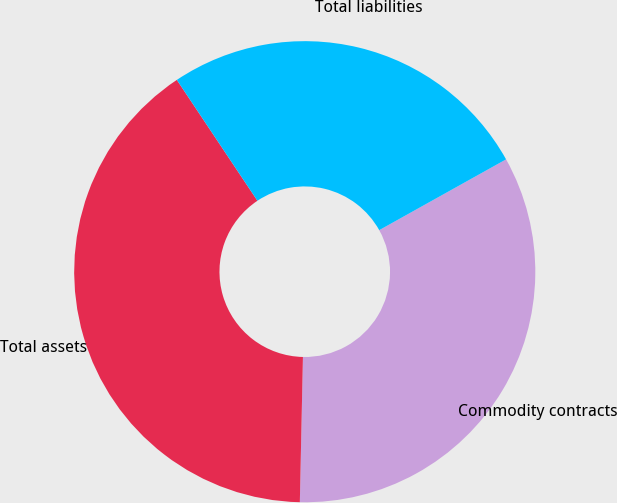Convert chart to OTSL. <chart><loc_0><loc_0><loc_500><loc_500><pie_chart><fcel>Commodity contracts<fcel>Total assets<fcel>Total liabilities<nl><fcel>33.44%<fcel>40.3%<fcel>26.26%<nl></chart> 